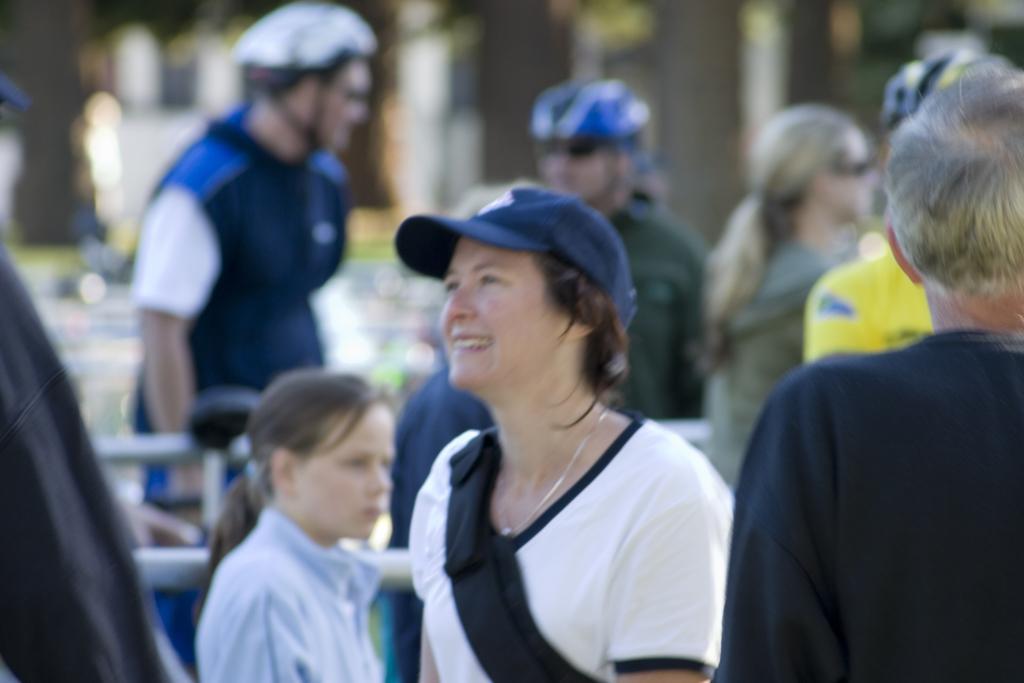Please provide a concise description of this image. In this image I can see few people are standing and wearing different color dresses. Background is blurred. 